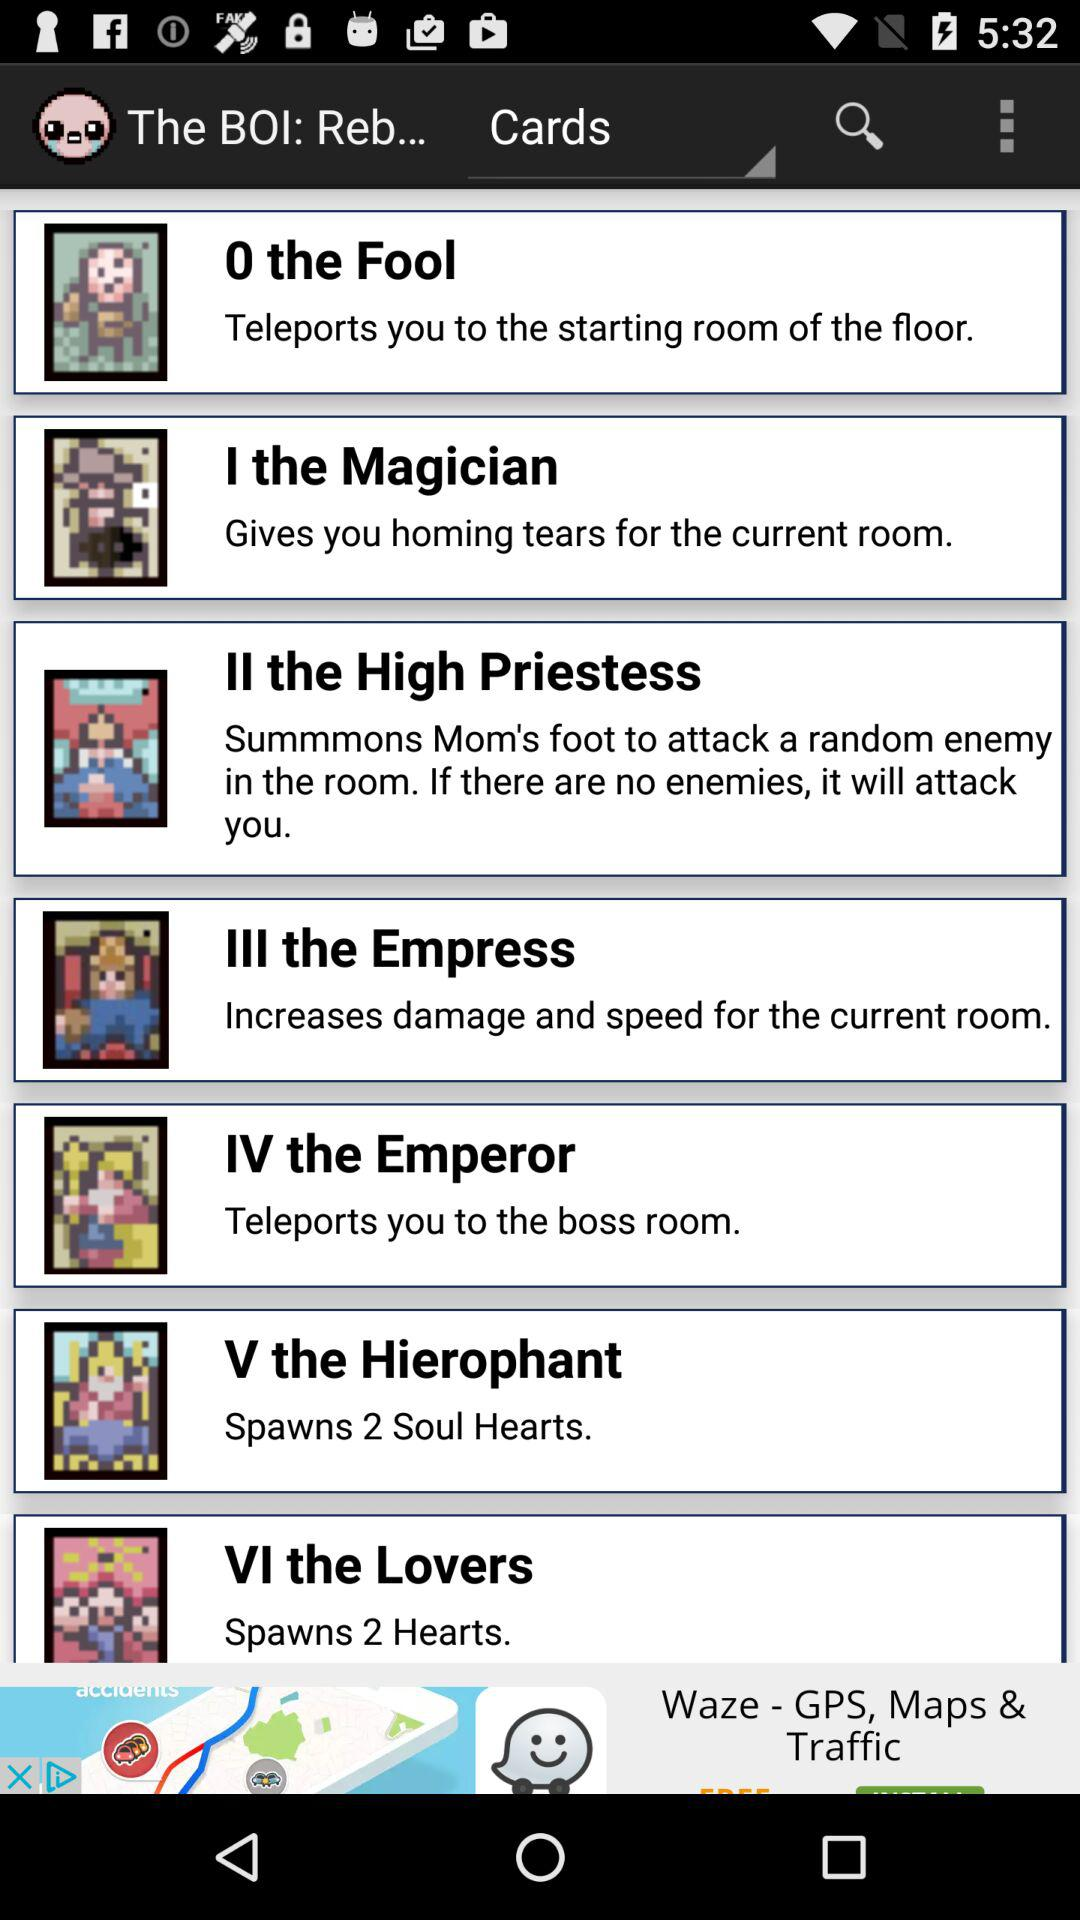How many soul hearts are spawned by the Hierophant card?
Answer the question using a single word or phrase. 2 